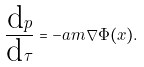Convert formula to latex. <formula><loc_0><loc_0><loc_500><loc_500>\frac { \text {d} p } { \text {d} \tau } = - a m \nabla \Phi ( x ) .</formula> 